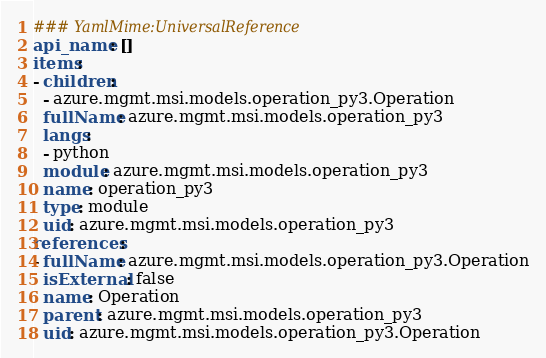Convert code to text. <code><loc_0><loc_0><loc_500><loc_500><_YAML_>### YamlMime:UniversalReference
api_name: []
items:
- children:
  - azure.mgmt.msi.models.operation_py3.Operation
  fullName: azure.mgmt.msi.models.operation_py3
  langs:
  - python
  module: azure.mgmt.msi.models.operation_py3
  name: operation_py3
  type: module
  uid: azure.mgmt.msi.models.operation_py3
references:
- fullName: azure.mgmt.msi.models.operation_py3.Operation
  isExternal: false
  name: Operation
  parent: azure.mgmt.msi.models.operation_py3
  uid: azure.mgmt.msi.models.operation_py3.Operation
</code> 